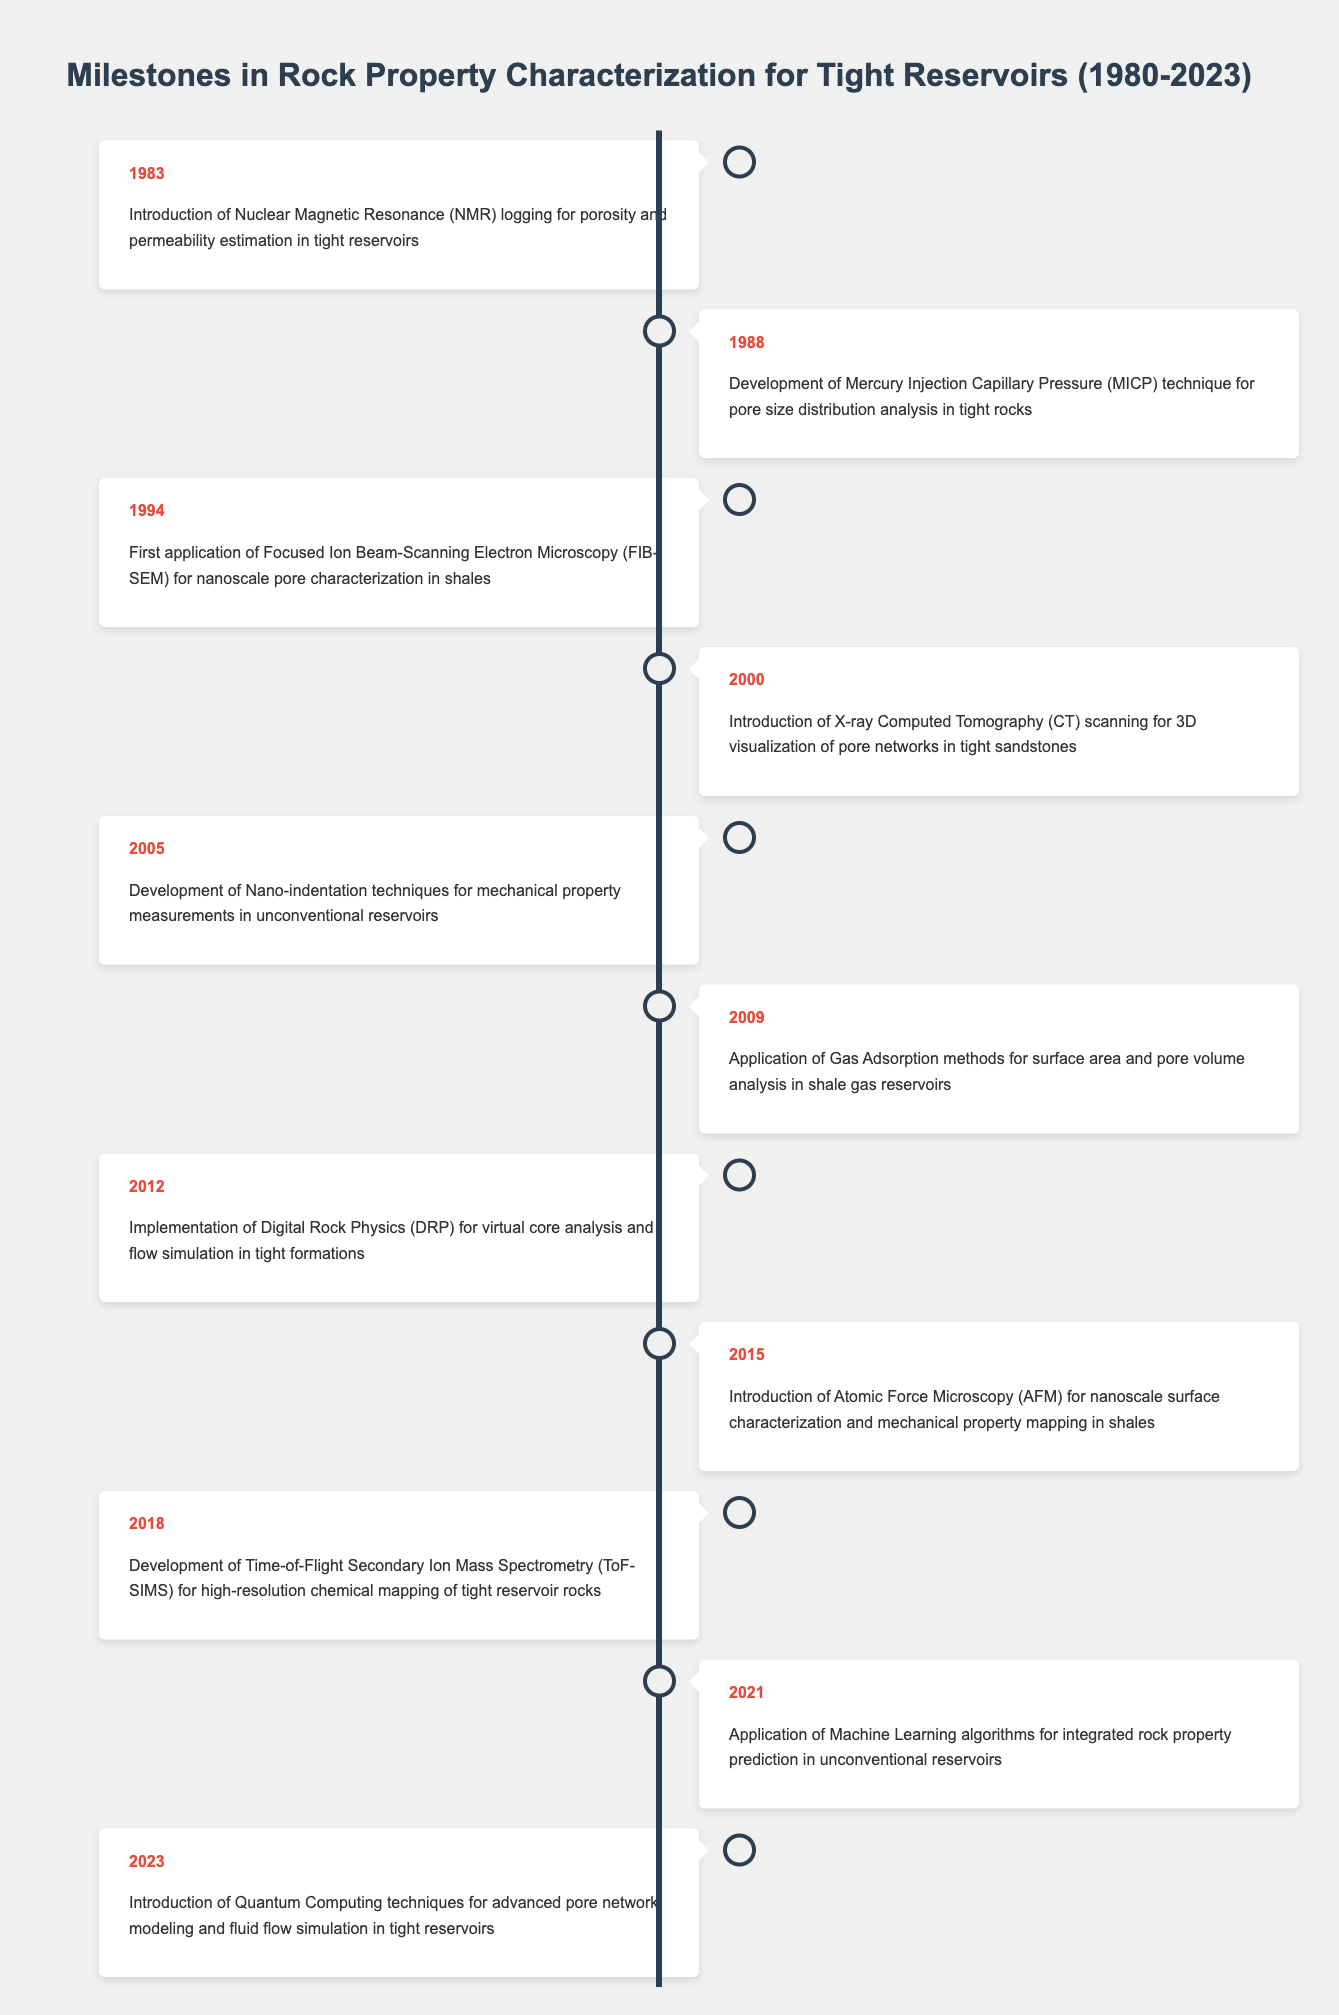What event occurred in 2000? The table indicates that in 2000, the event was the introduction of X-ray Computed Tomography (CT) scanning for 3D visualization of pore networks in tight sandstones.
Answer: Introduction of X-ray Computed Tomography (CT) scanning for 3D visualization of pore networks in tight sandstones What year did the development of Time-of-Flight Secondary Ion Mass Spectrometry (ToF-SIMS) take place? The table shows that the development of ToF-SIMS occurred in 2018, as highlighted in that row.
Answer: 2018 Which method was introduced first, NMR logging or MICP technique? According to the timeline, NMR logging was introduced in 1983, while the MICP technique was developed in 1988. Since 1983 is earlier than 1988, NMR logging was introduced first.
Answer: NMR logging How many events were recorded between 2000 and 2015? The years from 2000 to 2015 include the events of 2000, 2005, and 2015, which totals three events in that timeframe.
Answer: 3 Was Machine Learning algorithms applied before 2021? The table states that the application of Machine Learning algorithms occurred in 2021, so it had not been applied before that year.
Answer: No What is the interval in years between the introduction of NMR logging and the introduction of Quantum Computing techniques? NMR logging was introduced in 1983 and Quantum Computing was introduced in 2023. The difference is 2023 - 1983 = 40 years.
Answer: 40 years How many techniques were introduced in the 2010s? The techniques introduced during the 2010s are Digital Rock Physics in 2012, Atomic Force Microscopy in 2015, and Time-of-Flight Secondary Ion Mass Spectrometry in 2018, which sums up to three techniques introduced in that decade.
Answer: 3 Was there any development in pore characterization methods from 1983 to 2012? Yes, the table outlines multiple developments from NMR in 1983 to Digital Rock Physics in 2012, indicating progress in pore characterization methods.
Answer: Yes Which method was the last to be introduced as of 2023? The table shows that the last event listed is the introduction of Quantum Computing techniques, which occurred in 2023.
Answer: Quantum Computing techniques 